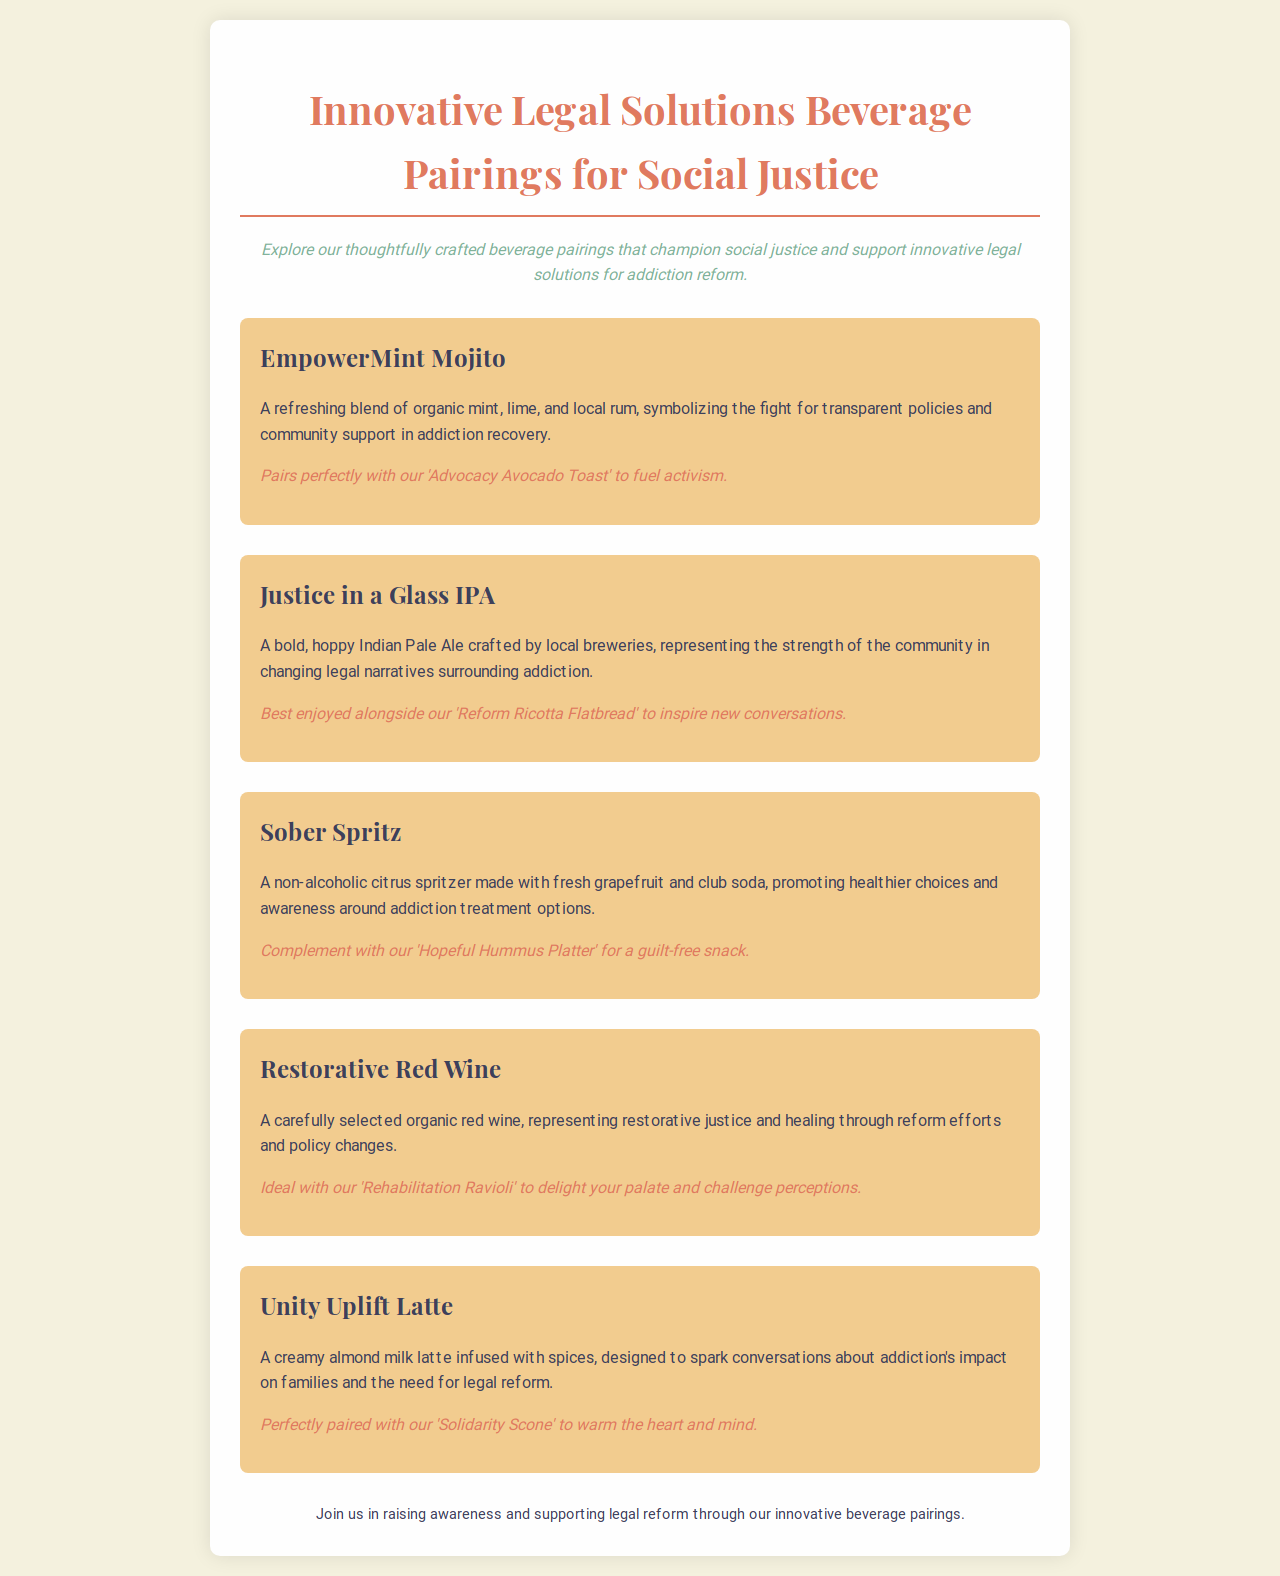What is the name of the beverage that pairs with 'Advocacy Avocado Toast'? The beverage that pairs with 'Advocacy Avocado Toast' is specifically mentioned in the description of the EmpowerMint Mojito.
Answer: EmpowerMint Mojito What type of beverage is the Sober Spritz? The Sober Spritz is described as a non-alcoholic beverage promoting healthier choices.
Answer: Non-alcoholic What symbol does the EmpowerMint Mojito represent? The EmpowerMint Mojito symbolizes the fight for transparent policies and community support in addiction recovery.
Answer: Transparent policies What is the main ingredient in the Unity Uplift Latte? The key ingredient in the Unity Uplift Latte is almond milk, as indicated in its description.
Answer: Almond milk Which beverage represents restorative justice? The Restorative Red Wine is indicated as a representation of restorative justice through reform efforts.
Answer: Restorative Red Wine What food item is recommended to pair with Justice in a Glass IPA? The document suggests pairing the Justice in a Glass IPA with the Reform Ricotta Flatbread.
Answer: Reform Ricotta Flatbread What color is associated with the background of the document? The background color of the document is light beige as specified in the style section.
Answer: Light beige How many beverages are listed in the menu? The total number of beverages in the menu is counted from the distinct beverage sections displayed.
Answer: Five 